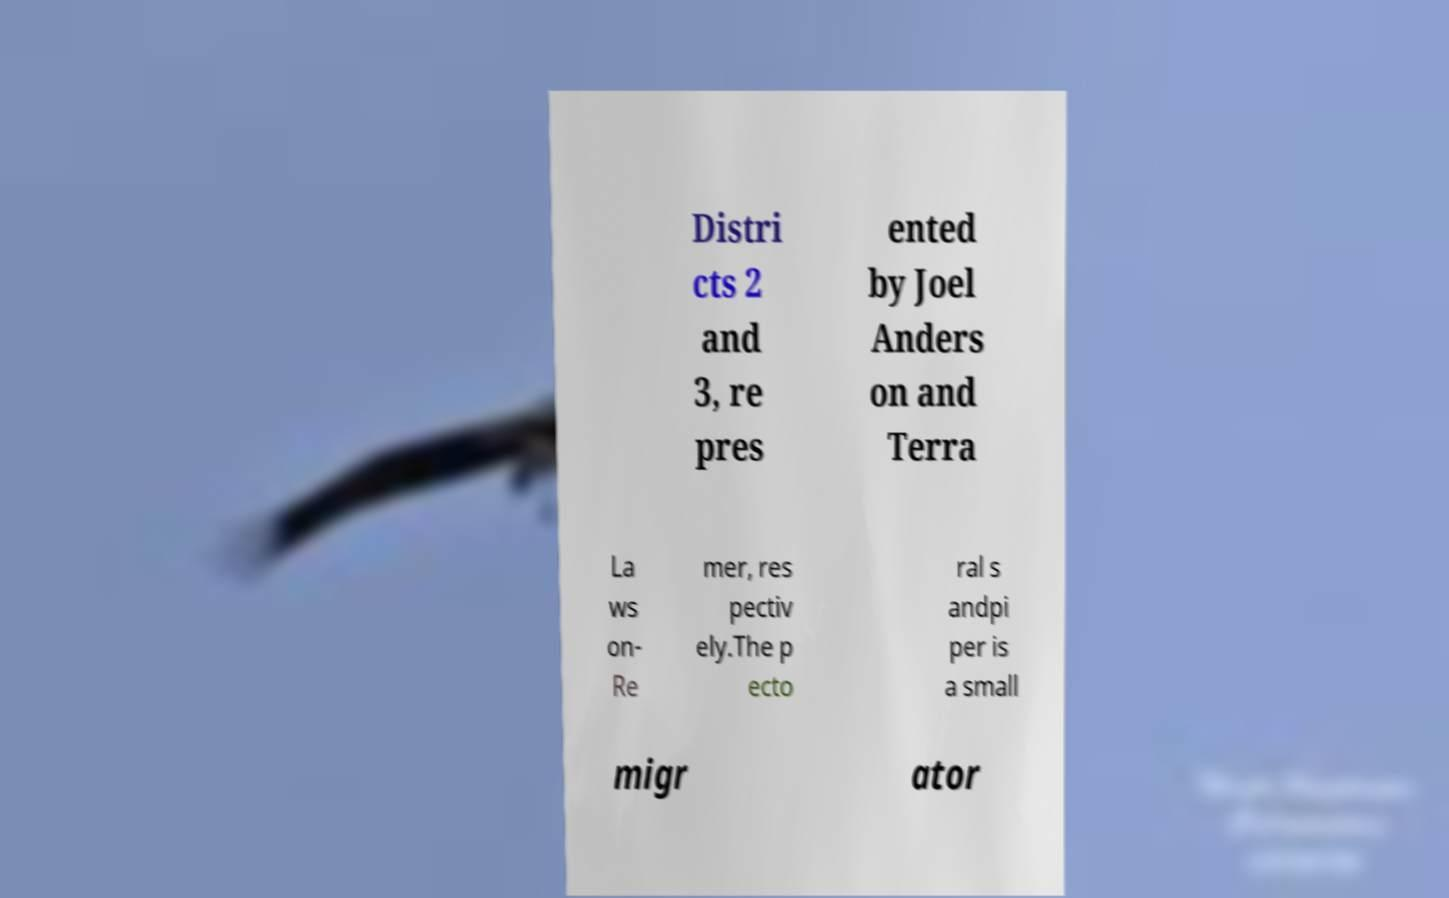For documentation purposes, I need the text within this image transcribed. Could you provide that? Distri cts 2 and 3, re pres ented by Joel Anders on and Terra La ws on- Re mer, res pectiv ely.The p ecto ral s andpi per is a small migr ator 